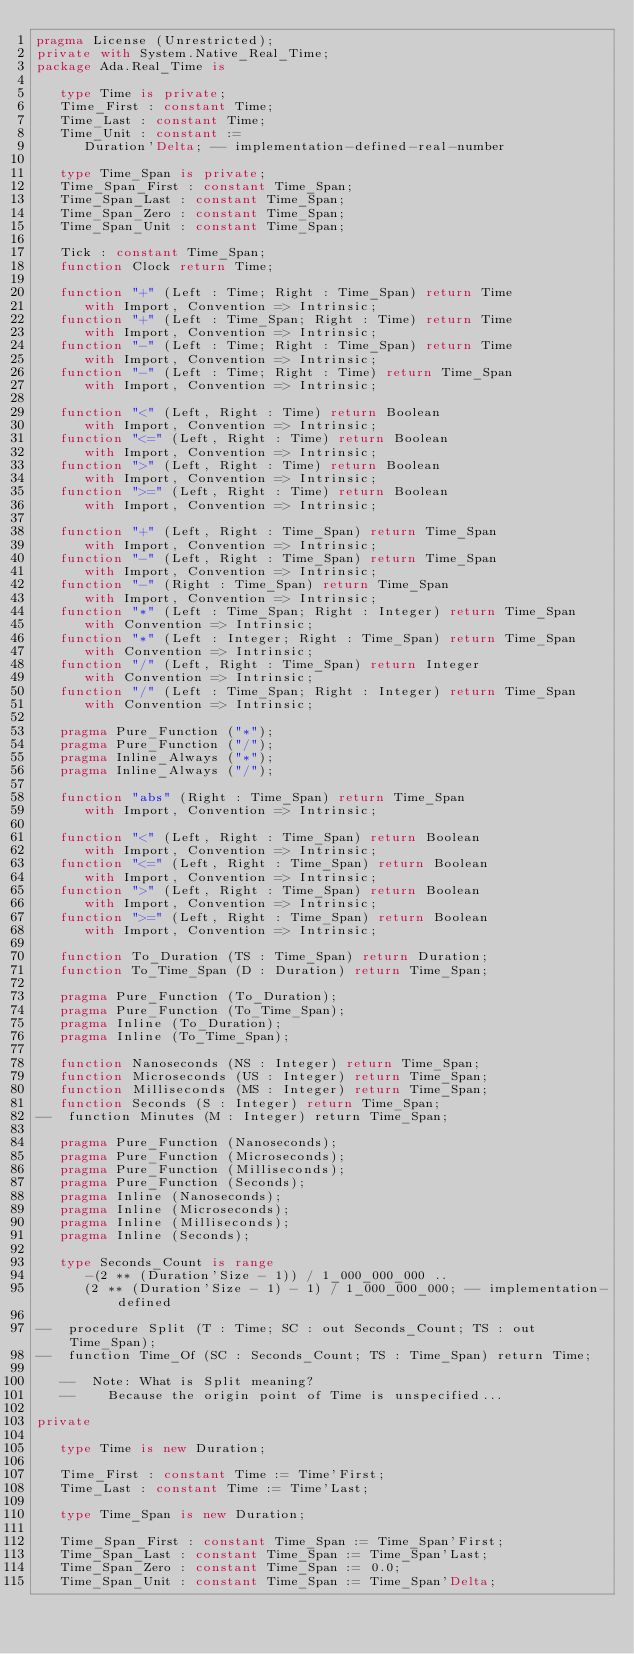Convert code to text. <code><loc_0><loc_0><loc_500><loc_500><_Ada_>pragma License (Unrestricted);
private with System.Native_Real_Time;
package Ada.Real_Time is

   type Time is private;
   Time_First : constant Time;
   Time_Last : constant Time;
   Time_Unit : constant :=
      Duration'Delta; -- implementation-defined-real-number

   type Time_Span is private;
   Time_Span_First : constant Time_Span;
   Time_Span_Last : constant Time_Span;
   Time_Span_Zero : constant Time_Span;
   Time_Span_Unit : constant Time_Span;

   Tick : constant Time_Span;
   function Clock return Time;

   function "+" (Left : Time; Right : Time_Span) return Time
      with Import, Convention => Intrinsic;
   function "+" (Left : Time_Span; Right : Time) return Time
      with Import, Convention => Intrinsic;
   function "-" (Left : Time; Right : Time_Span) return Time
      with Import, Convention => Intrinsic;
   function "-" (Left : Time; Right : Time) return Time_Span
      with Import, Convention => Intrinsic;

   function "<" (Left, Right : Time) return Boolean
      with Import, Convention => Intrinsic;
   function "<=" (Left, Right : Time) return Boolean
      with Import, Convention => Intrinsic;
   function ">" (Left, Right : Time) return Boolean
      with Import, Convention => Intrinsic;
   function ">=" (Left, Right : Time) return Boolean
      with Import, Convention => Intrinsic;

   function "+" (Left, Right : Time_Span) return Time_Span
      with Import, Convention => Intrinsic;
   function "-" (Left, Right : Time_Span) return Time_Span
      with Import, Convention => Intrinsic;
   function "-" (Right : Time_Span) return Time_Span
      with Import, Convention => Intrinsic;
   function "*" (Left : Time_Span; Right : Integer) return Time_Span
      with Convention => Intrinsic;
   function "*" (Left : Integer; Right : Time_Span) return Time_Span
      with Convention => Intrinsic;
   function "/" (Left, Right : Time_Span) return Integer
      with Convention => Intrinsic;
   function "/" (Left : Time_Span; Right : Integer) return Time_Span
      with Convention => Intrinsic;

   pragma Pure_Function ("*");
   pragma Pure_Function ("/");
   pragma Inline_Always ("*");
   pragma Inline_Always ("/");

   function "abs" (Right : Time_Span) return Time_Span
      with Import, Convention => Intrinsic;

   function "<" (Left, Right : Time_Span) return Boolean
      with Import, Convention => Intrinsic;
   function "<=" (Left, Right : Time_Span) return Boolean
      with Import, Convention => Intrinsic;
   function ">" (Left, Right : Time_Span) return Boolean
      with Import, Convention => Intrinsic;
   function ">=" (Left, Right : Time_Span) return Boolean
      with Import, Convention => Intrinsic;

   function To_Duration (TS : Time_Span) return Duration;
   function To_Time_Span (D : Duration) return Time_Span;

   pragma Pure_Function (To_Duration);
   pragma Pure_Function (To_Time_Span);
   pragma Inline (To_Duration);
   pragma Inline (To_Time_Span);

   function Nanoseconds (NS : Integer) return Time_Span;
   function Microseconds (US : Integer) return Time_Span;
   function Milliseconds (MS : Integer) return Time_Span;
   function Seconds (S : Integer) return Time_Span;
--  function Minutes (M : Integer) return Time_Span;

   pragma Pure_Function (Nanoseconds);
   pragma Pure_Function (Microseconds);
   pragma Pure_Function (Milliseconds);
   pragma Pure_Function (Seconds);
   pragma Inline (Nanoseconds);
   pragma Inline (Microseconds);
   pragma Inline (Milliseconds);
   pragma Inline (Seconds);

   type Seconds_Count is range
      -(2 ** (Duration'Size - 1)) / 1_000_000_000 ..
      (2 ** (Duration'Size - 1) - 1) / 1_000_000_000; -- implementation-defined

--  procedure Split (T : Time; SC : out Seconds_Count; TS : out Time_Span);
--  function Time_Of (SC : Seconds_Count; TS : Time_Span) return Time;

   --  Note: What is Split meaning?
   --    Because the origin point of Time is unspecified...

private

   type Time is new Duration;

   Time_First : constant Time := Time'First;
   Time_Last : constant Time := Time'Last;

   type Time_Span is new Duration;

   Time_Span_First : constant Time_Span := Time_Span'First;
   Time_Span_Last : constant Time_Span := Time_Span'Last;
   Time_Span_Zero : constant Time_Span := 0.0;
   Time_Span_Unit : constant Time_Span := Time_Span'Delta;
</code> 